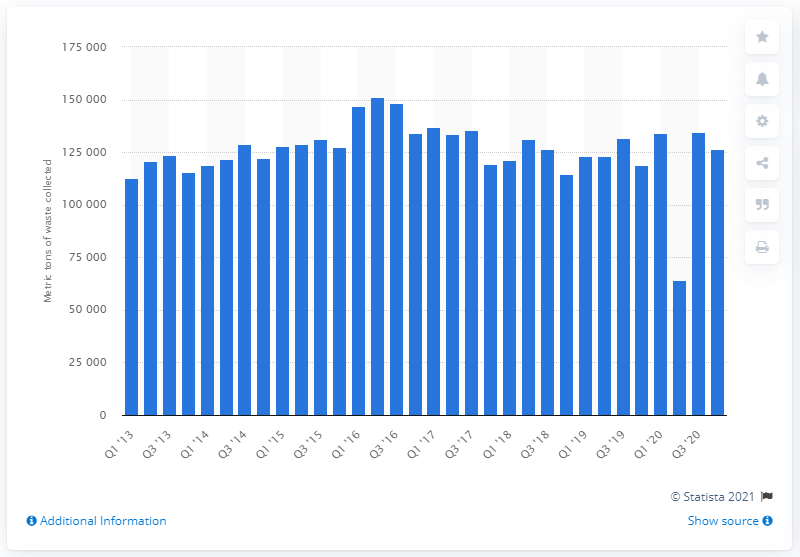Identify some key points in this picture. In the second quarter of 2020, a total of 64,424 kilograms of WEEE was collected. 